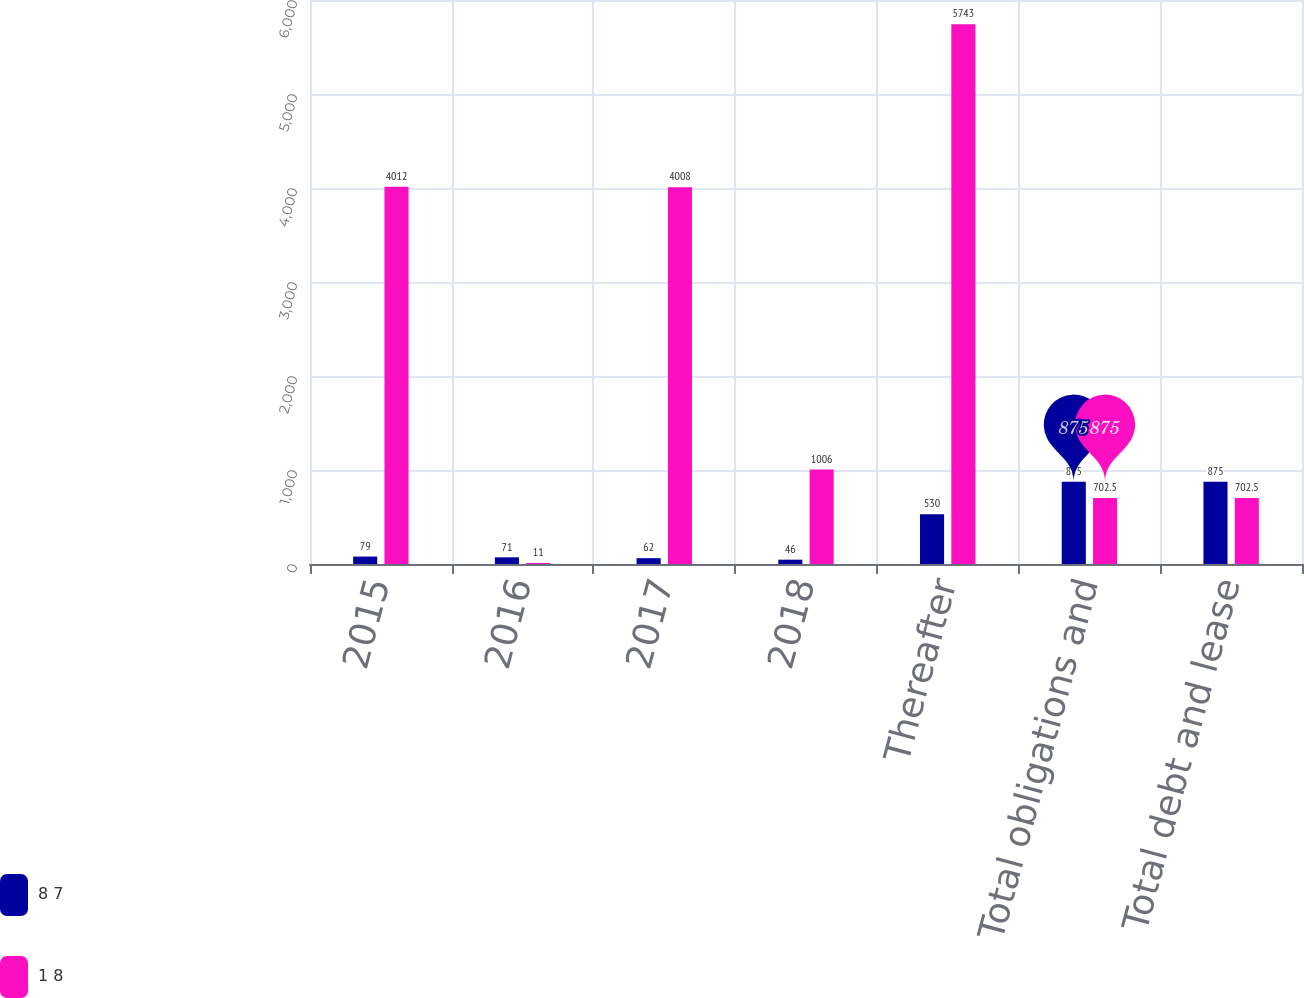Convert chart. <chart><loc_0><loc_0><loc_500><loc_500><stacked_bar_chart><ecel><fcel>2015<fcel>2016<fcel>2017<fcel>2018<fcel>Thereafter<fcel>Total obligations and<fcel>Total debt and lease<nl><fcel>8 7<fcel>79<fcel>71<fcel>62<fcel>46<fcel>530<fcel>875<fcel>875<nl><fcel>1 8<fcel>4012<fcel>11<fcel>4008<fcel>1006<fcel>5743<fcel>702.5<fcel>702.5<nl></chart> 